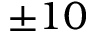Convert formula to latex. <formula><loc_0><loc_0><loc_500><loc_500>\pm 1 0</formula> 